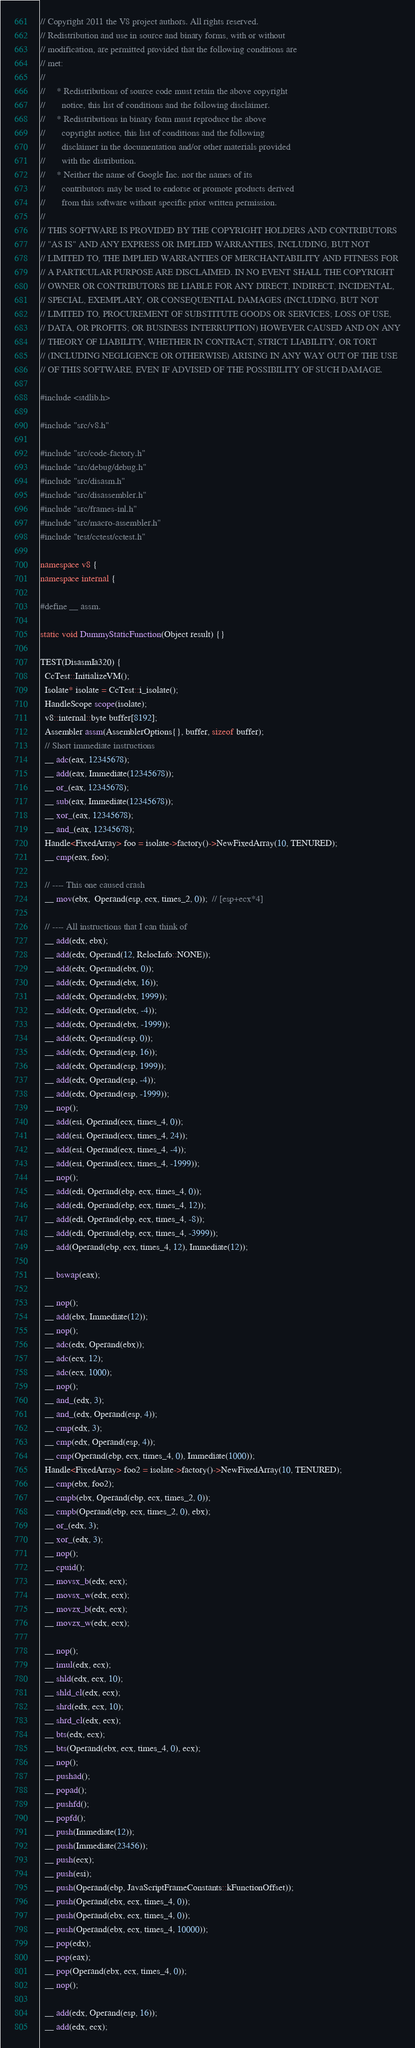<code> <loc_0><loc_0><loc_500><loc_500><_C++_>// Copyright 2011 the V8 project authors. All rights reserved.
// Redistribution and use in source and binary forms, with or without
// modification, are permitted provided that the following conditions are
// met:
//
//     * Redistributions of source code must retain the above copyright
//       notice, this list of conditions and the following disclaimer.
//     * Redistributions in binary form must reproduce the above
//       copyright notice, this list of conditions and the following
//       disclaimer in the documentation and/or other materials provided
//       with the distribution.
//     * Neither the name of Google Inc. nor the names of its
//       contributors may be used to endorse or promote products derived
//       from this software without specific prior written permission.
//
// THIS SOFTWARE IS PROVIDED BY THE COPYRIGHT HOLDERS AND CONTRIBUTORS
// "AS IS" AND ANY EXPRESS OR IMPLIED WARRANTIES, INCLUDING, BUT NOT
// LIMITED TO, THE IMPLIED WARRANTIES OF MERCHANTABILITY AND FITNESS FOR
// A PARTICULAR PURPOSE ARE DISCLAIMED. IN NO EVENT SHALL THE COPYRIGHT
// OWNER OR CONTRIBUTORS BE LIABLE FOR ANY DIRECT, INDIRECT, INCIDENTAL,
// SPECIAL, EXEMPLARY, OR CONSEQUENTIAL DAMAGES (INCLUDING, BUT NOT
// LIMITED TO, PROCUREMENT OF SUBSTITUTE GOODS OR SERVICES; LOSS OF USE,
// DATA, OR PROFITS; OR BUSINESS INTERRUPTION) HOWEVER CAUSED AND ON ANY
// THEORY OF LIABILITY, WHETHER IN CONTRACT, STRICT LIABILITY, OR TORT
// (INCLUDING NEGLIGENCE OR OTHERWISE) ARISING IN ANY WAY OUT OF THE USE
// OF THIS SOFTWARE, EVEN IF ADVISED OF THE POSSIBILITY OF SUCH DAMAGE.

#include <stdlib.h>

#include "src/v8.h"

#include "src/code-factory.h"
#include "src/debug/debug.h"
#include "src/disasm.h"
#include "src/disassembler.h"
#include "src/frames-inl.h"
#include "src/macro-assembler.h"
#include "test/cctest/cctest.h"

namespace v8 {
namespace internal {

#define __ assm.

static void DummyStaticFunction(Object result) {}

TEST(DisasmIa320) {
  CcTest::InitializeVM();
  Isolate* isolate = CcTest::i_isolate();
  HandleScope scope(isolate);
  v8::internal::byte buffer[8192];
  Assembler assm(AssemblerOptions{}, buffer, sizeof buffer);
  // Short immediate instructions
  __ adc(eax, 12345678);
  __ add(eax, Immediate(12345678));
  __ or_(eax, 12345678);
  __ sub(eax, Immediate(12345678));
  __ xor_(eax, 12345678);
  __ and_(eax, 12345678);
  Handle<FixedArray> foo = isolate->factory()->NewFixedArray(10, TENURED);
  __ cmp(eax, foo);

  // ---- This one caused crash
  __ mov(ebx,  Operand(esp, ecx, times_2, 0));  // [esp+ecx*4]

  // ---- All instructions that I can think of
  __ add(edx, ebx);
  __ add(edx, Operand(12, RelocInfo::NONE));
  __ add(edx, Operand(ebx, 0));
  __ add(edx, Operand(ebx, 16));
  __ add(edx, Operand(ebx, 1999));
  __ add(edx, Operand(ebx, -4));
  __ add(edx, Operand(ebx, -1999));
  __ add(edx, Operand(esp, 0));
  __ add(edx, Operand(esp, 16));
  __ add(edx, Operand(esp, 1999));
  __ add(edx, Operand(esp, -4));
  __ add(edx, Operand(esp, -1999));
  __ nop();
  __ add(esi, Operand(ecx, times_4, 0));
  __ add(esi, Operand(ecx, times_4, 24));
  __ add(esi, Operand(ecx, times_4, -4));
  __ add(esi, Operand(ecx, times_4, -1999));
  __ nop();
  __ add(edi, Operand(ebp, ecx, times_4, 0));
  __ add(edi, Operand(ebp, ecx, times_4, 12));
  __ add(edi, Operand(ebp, ecx, times_4, -8));
  __ add(edi, Operand(ebp, ecx, times_4, -3999));
  __ add(Operand(ebp, ecx, times_4, 12), Immediate(12));

  __ bswap(eax);

  __ nop();
  __ add(ebx, Immediate(12));
  __ nop();
  __ adc(edx, Operand(ebx));
  __ adc(ecx, 12);
  __ adc(ecx, 1000);
  __ nop();
  __ and_(edx, 3);
  __ and_(edx, Operand(esp, 4));
  __ cmp(edx, 3);
  __ cmp(edx, Operand(esp, 4));
  __ cmp(Operand(ebp, ecx, times_4, 0), Immediate(1000));
  Handle<FixedArray> foo2 = isolate->factory()->NewFixedArray(10, TENURED);
  __ cmp(ebx, foo2);
  __ cmpb(ebx, Operand(ebp, ecx, times_2, 0));
  __ cmpb(Operand(ebp, ecx, times_2, 0), ebx);
  __ or_(edx, 3);
  __ xor_(edx, 3);
  __ nop();
  __ cpuid();
  __ movsx_b(edx, ecx);
  __ movsx_w(edx, ecx);
  __ movzx_b(edx, ecx);
  __ movzx_w(edx, ecx);

  __ nop();
  __ imul(edx, ecx);
  __ shld(edx, ecx, 10);
  __ shld_cl(edx, ecx);
  __ shrd(edx, ecx, 10);
  __ shrd_cl(edx, ecx);
  __ bts(edx, ecx);
  __ bts(Operand(ebx, ecx, times_4, 0), ecx);
  __ nop();
  __ pushad();
  __ popad();
  __ pushfd();
  __ popfd();
  __ push(Immediate(12));
  __ push(Immediate(23456));
  __ push(ecx);
  __ push(esi);
  __ push(Operand(ebp, JavaScriptFrameConstants::kFunctionOffset));
  __ push(Operand(ebx, ecx, times_4, 0));
  __ push(Operand(ebx, ecx, times_4, 0));
  __ push(Operand(ebx, ecx, times_4, 10000));
  __ pop(edx);
  __ pop(eax);
  __ pop(Operand(ebx, ecx, times_4, 0));
  __ nop();

  __ add(edx, Operand(esp, 16));
  __ add(edx, ecx);</code> 